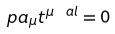Convert formula to latex. <formula><loc_0><loc_0><loc_500><loc_500>\ p a _ { \mu } t ^ { \mu \ a l } = 0</formula> 